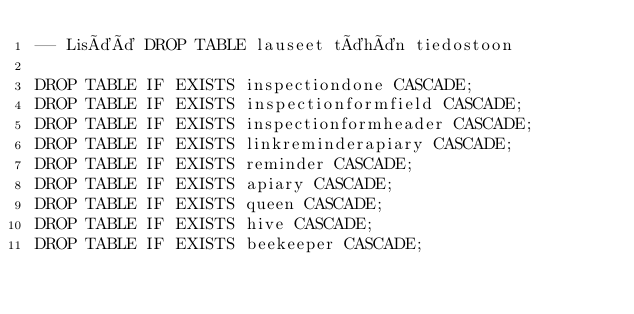<code> <loc_0><loc_0><loc_500><loc_500><_SQL_>-- Lisää DROP TABLE lauseet tähän tiedostoon

DROP TABLE IF EXISTS inspectiondone CASCADE;
DROP TABLE IF EXISTS inspectionformfield CASCADE;
DROP TABLE IF EXISTS inspectionformheader CASCADE;
DROP TABLE IF EXISTS linkreminderapiary CASCADE;
DROP TABLE IF EXISTS reminder CASCADE;
DROP TABLE IF EXISTS apiary CASCADE;
DROP TABLE IF EXISTS queen CASCADE;
DROP TABLE IF EXISTS hive CASCADE;
DROP TABLE IF EXISTS beekeeper CASCADE;
</code> 